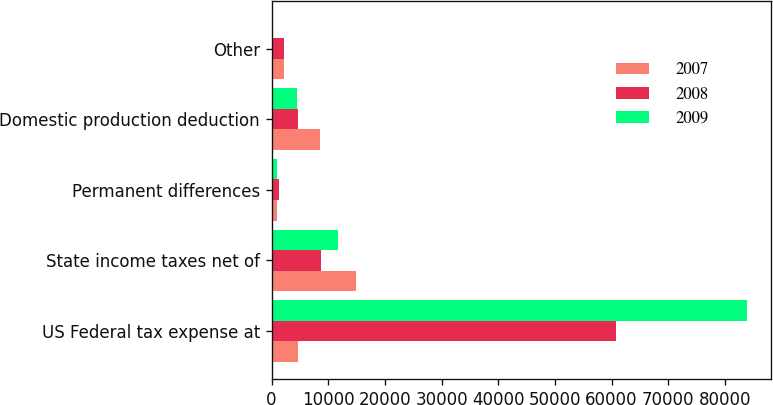<chart> <loc_0><loc_0><loc_500><loc_500><stacked_bar_chart><ecel><fcel>US Federal tax expense at<fcel>State income taxes net of<fcel>Permanent differences<fcel>Domestic production deduction<fcel>Other<nl><fcel>2007<fcel>4584<fcel>14819<fcel>977<fcel>8495<fcel>2168<nl><fcel>2008<fcel>60717<fcel>8676<fcel>1344<fcel>4733<fcel>2129<nl><fcel>2009<fcel>83915<fcel>11790<fcel>881<fcel>4435<fcel>39<nl></chart> 